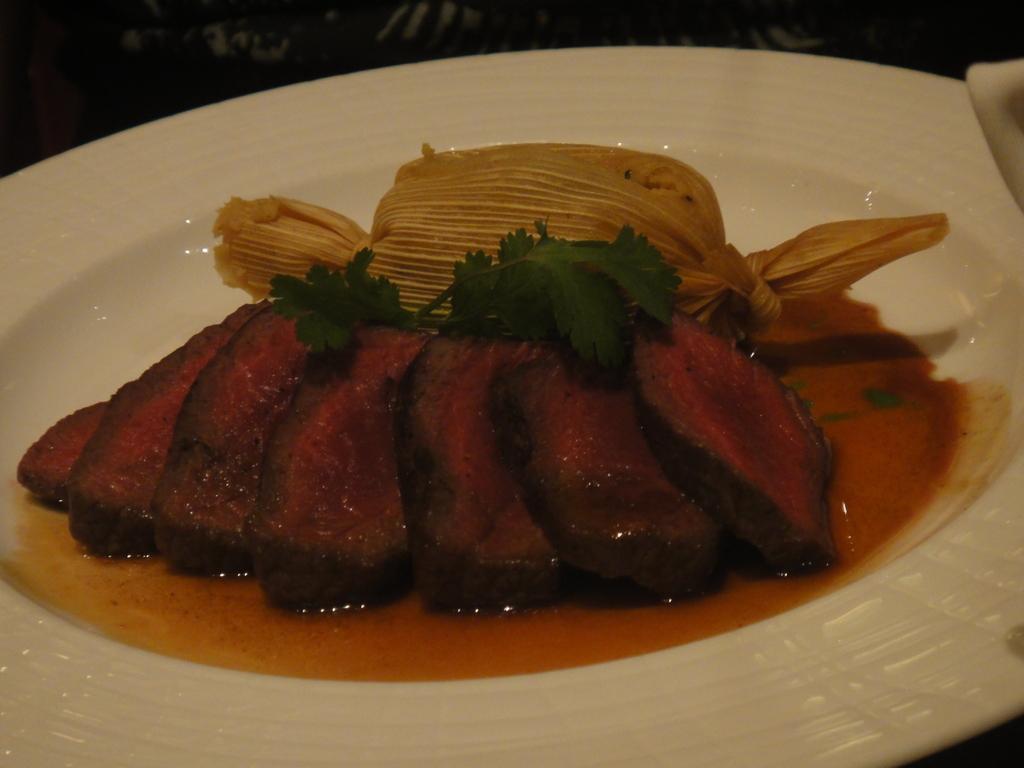Describe this image in one or two sentences. In this picture I can see the fried fish pieces, mint, oil and other food item in a white plate. This plate is kept on the table. 